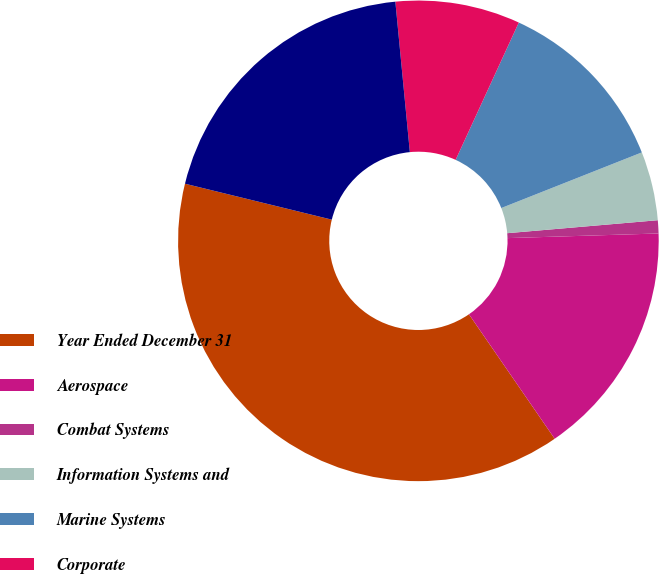Convert chart. <chart><loc_0><loc_0><loc_500><loc_500><pie_chart><fcel>Year Ended December 31<fcel>Aerospace<fcel>Combat Systems<fcel>Information Systems and<fcel>Marine Systems<fcel>Corporate<fcel>Total<nl><fcel>38.42%<fcel>15.89%<fcel>0.88%<fcel>4.63%<fcel>12.14%<fcel>8.39%<fcel>19.65%<nl></chart> 